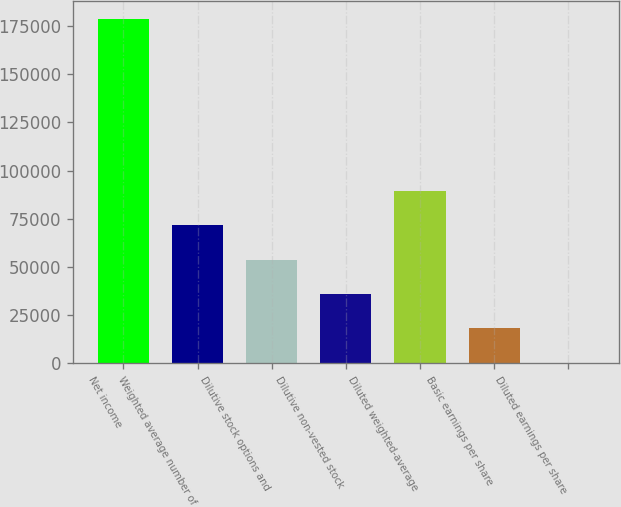<chart> <loc_0><loc_0><loc_500><loc_500><bar_chart><fcel>Net income<fcel>Weighted average number of<fcel>Dilutive stock options and<fcel>Dilutive non-vested stock<fcel>Diluted weighted-average<fcel>Basic earnings per share<fcel>Diluted earnings per share<nl><fcel>178981<fcel>71595.8<fcel>53698.3<fcel>35800.7<fcel>89493.3<fcel>17903.2<fcel>5.64<nl></chart> 